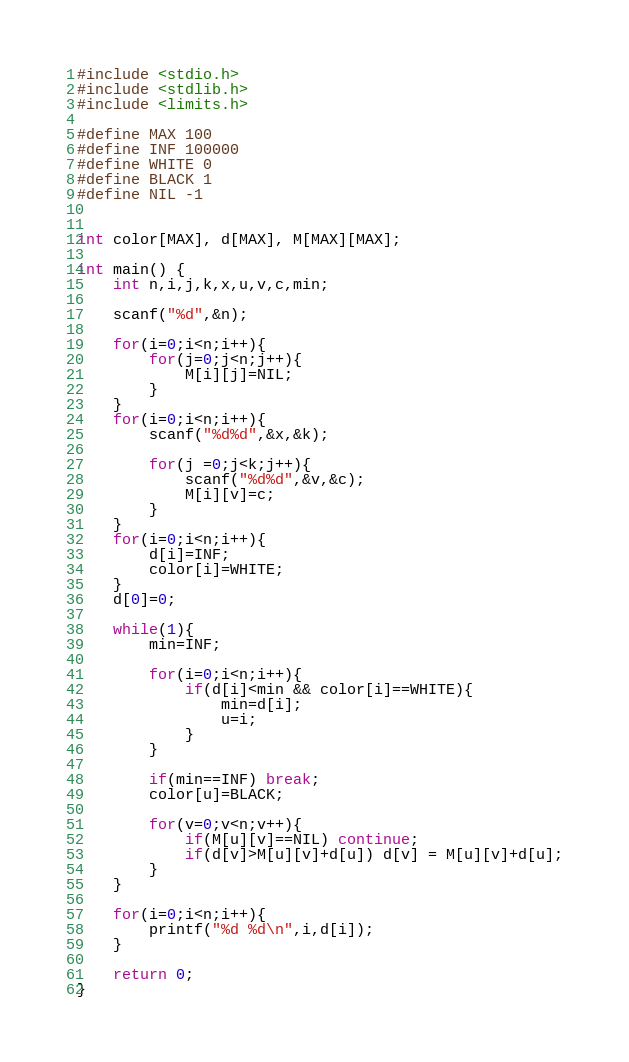Convert code to text. <code><loc_0><loc_0><loc_500><loc_500><_C_>#include <stdio.h>
#include <stdlib.h>
#include <limits.h>

#define MAX 100
#define INF 100000
#define WHITE 0
#define BLACK 1
#define NIL -1


int color[MAX], d[MAX], M[MAX][MAX];

int main() {
    int n,i,j,k,x,u,v,c,min;
    
    scanf("%d",&n);
    
    for(i=0;i<n;i++){
        for(j=0;j<n;j++){
            M[i][j]=NIL;
        }
    }
    for(i=0;i<n;i++){
        scanf("%d%d",&x,&k);
        
        for(j =0;j<k;j++){
            scanf("%d%d",&v,&c);
            M[i][v]=c;
        }
    }
    for(i=0;i<n;i++){
        d[i]=INF;
        color[i]=WHITE;
    }
    d[0]=0;
    
    while(1){
        min=INF;
        
        for(i=0;i<n;i++){
            if(d[i]<min && color[i]==WHITE){
                min=d[i];
                u=i;
            }
        }
        
        if(min==INF) break;
        color[u]=BLACK;
        
        for(v=0;v<n;v++){
            if(M[u][v]==NIL) continue;
            if(d[v]>M[u][v]+d[u]) d[v] = M[u][v]+d[u];
        }
    }
    
    for(i=0;i<n;i++){
        printf("%d %d\n",i,d[i]);
    }
    
    return 0;
}</code> 